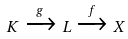<formula> <loc_0><loc_0><loc_500><loc_500>K \xrightarrow { g } L \xrightarrow { f } X</formula> 